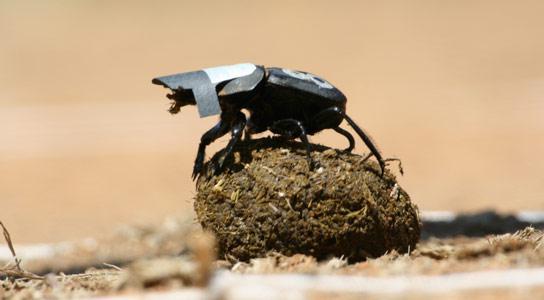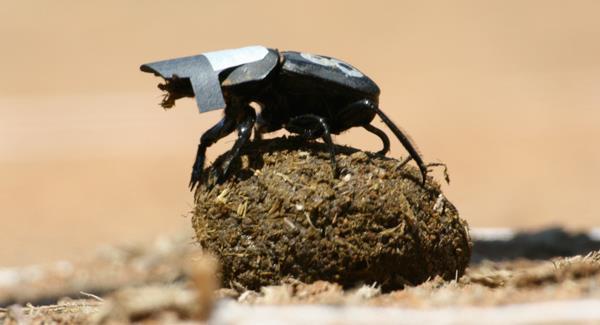The first image is the image on the left, the second image is the image on the right. Evaluate the accuracy of this statement regarding the images: "The beetle in the image on the left is sitting on top the clod of dirt.". Is it true? Answer yes or no. Yes. 